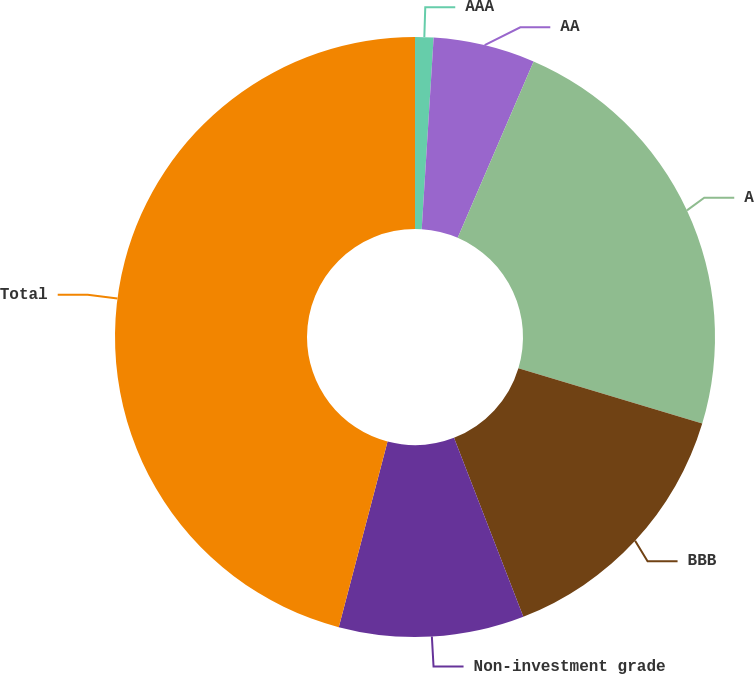<chart> <loc_0><loc_0><loc_500><loc_500><pie_chart><fcel>AAA<fcel>AA<fcel>A<fcel>BBB<fcel>Non-investment grade<fcel>Total<nl><fcel>0.99%<fcel>5.48%<fcel>23.19%<fcel>14.46%<fcel>9.97%<fcel>45.91%<nl></chart> 